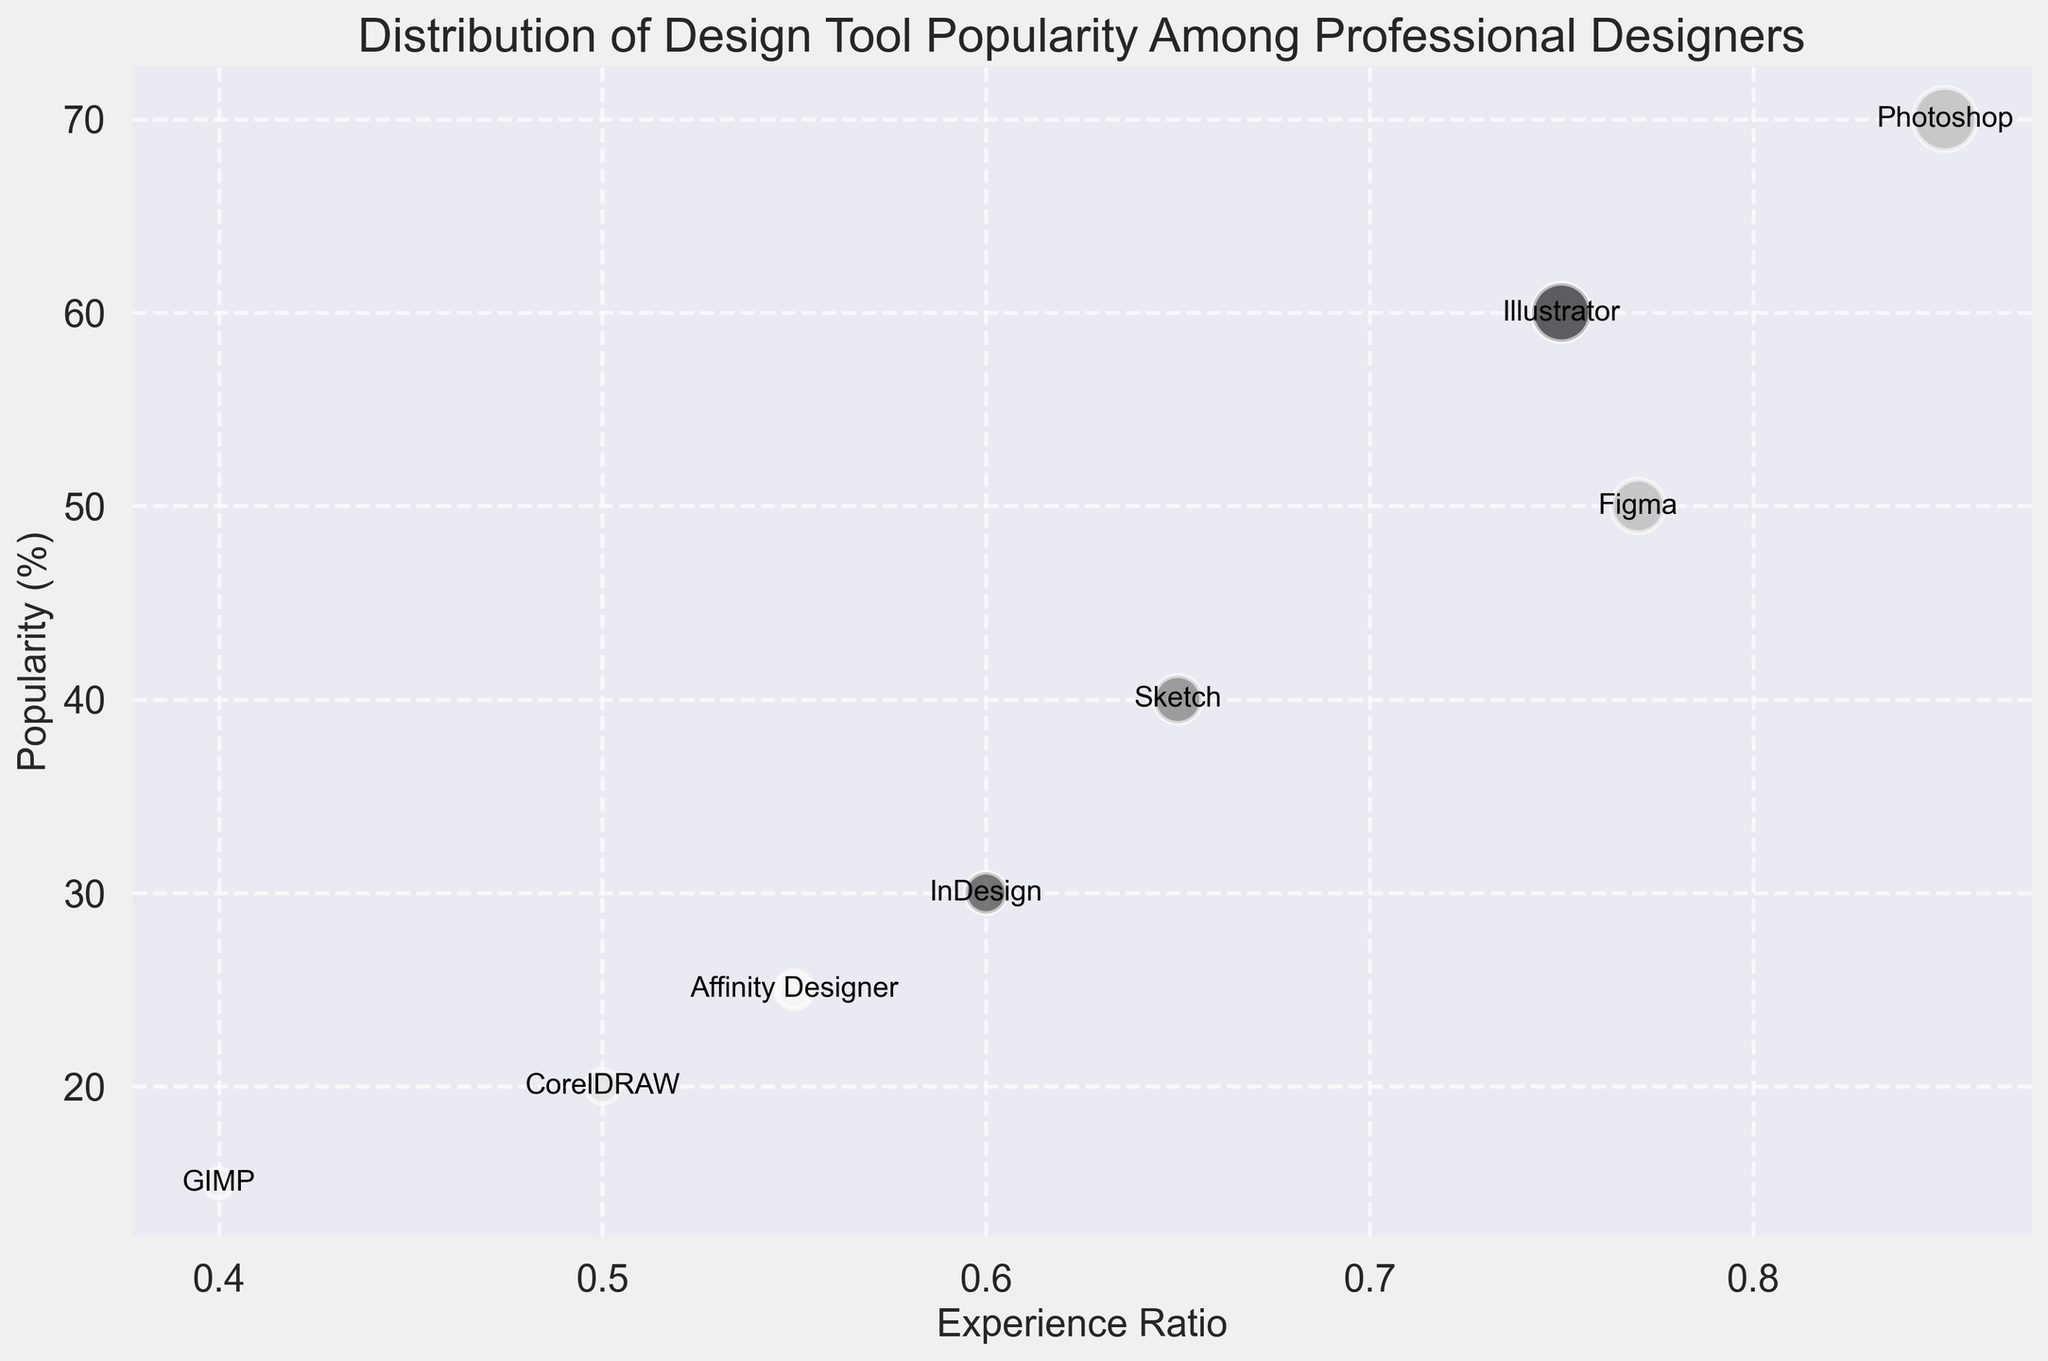Which tool has the highest popularity? By looking at the vertical positioning of the bubbles, the one placed highest represents the tool with the highest popularity.
Answer: Photoshop Which design tool has the lowest experience ratio? By observing the horizontal placement of the bubbles, the tool positioned furthest to the left has the lowest experience ratio.
Answer: GIMP How does the popularity of Figma compare to Illustrator? The Figma bubble is placed above or below the Illustrator bubble depending on its vertical position, which represents popularity.
Answer: Figma is less popular than Illustrator Which tools have a popularity of at least 50%? Identify the bubbles positioned at or above the 50% mark on the y-axis.
Answer: Photoshop, Illustrator, Sketch, Figma Is the tool with the highest experience ratio the most popular? The highest experience ratio bubble should align vertically with the highest popularity bubble if they are the same.
Answer: No Which two design tools have the closest popularity ratings? Find two bubbles that are vertically closest to each other.
Answer: Figma and Sketch What's the average popularity of tools with an experience ratio less than 0.6? Identify tools with less than 0.6 experience ratio, sum their popularity values and divide by the number of such tools.
Answer: Sum(30 + 20 + 25 + 15) / 4 = 22.5 Which tool appears to have the largest bubble size and what does it represent? Compare the visual size of bubbles; the largest one correlates with the tool having the most significant popularity as bubble size scales with popularity.
Answer: Photoshop, and it represents its 70% popularity Which tool has both the lowest popularity and experience ratio? Identify the bubble with the lowest vertical and horizontal position.
Answer: GIMP 